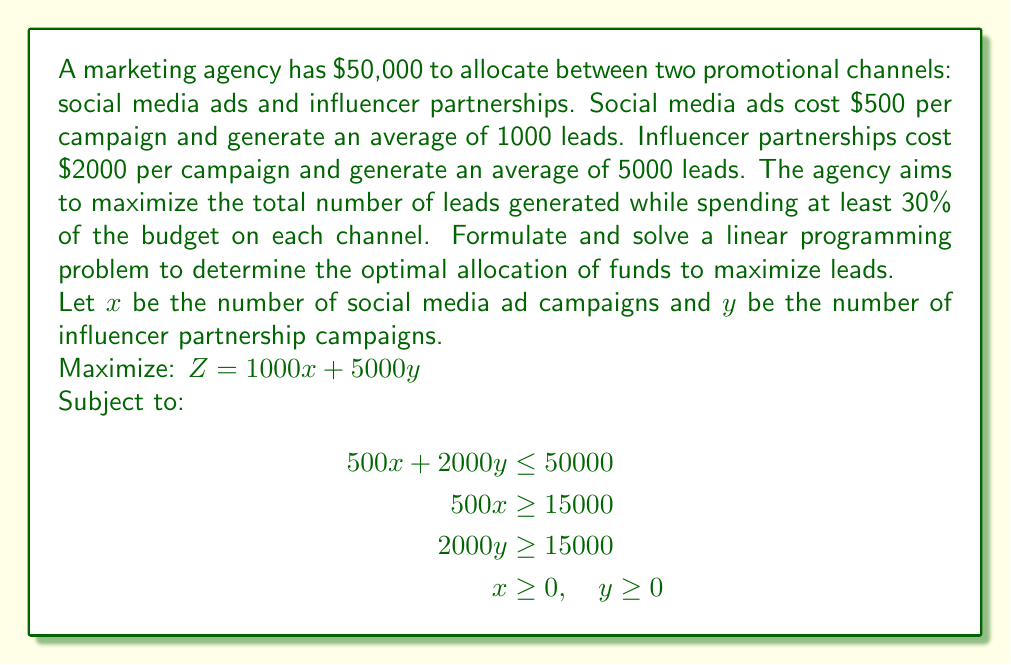Can you answer this question? To solve this linear programming problem, we'll follow these steps:

1. Identify the constraints:
   - Budget constraint: $500x + 2000y \leq 50000$
   - Minimum 30% on social media: $500x \geq 15000$
   - Minimum 30% on influencers: $2000y \geq 15000$
   - Non-negativity: $x \geq 0$, $y \geq 0$

2. Simplify the constraints:
   - $x + 4y \leq 100$
   - $x \geq 30$
   - $y \geq 7.5$

3. Plot the constraints and identify the feasible region:
   [asy]
   import graph;
   size(200);
   xaxis("x", 0, 100, Arrow);
   yaxis("y", 0, 25, Arrow);
   draw((30,0)--(30,17.5)--(0,25), dashed);
   draw((0,7.5)--(92.5,7.5)--(100,0), dashed);
   fill((30,7.5)--(30,17.5)--(92.5,7.5)--cycle, palegreen);
   label("Feasible Region", (50,10), N);
   [/asy]

4. Identify the corner points of the feasible region:
   A(30, 7.5), B(30, 17.5), C(92.5, 7.5)

5. Evaluate the objective function at each corner point:
   A: $Z = 1000(30) + 5000(7.5) = 67,500$
   B: $Z = 1000(30) + 5000(17.5) = 117,500$
   C: $Z = 1000(92.5) + 5000(7.5) = 130,000$

6. The maximum value of $Z$ occurs at point C(92.5, 7.5).

7. Round down to integer values: $x = 92$ social media campaigns, $y = 7$ influencer campaigns.

8. Calculate the total leads generated:
   $1000(92) + 5000(7) = 92,000 + 35,000 = 127,000$ leads
Answer: 92 social media campaigns, 7 influencer campaigns, generating 127,000 leads 